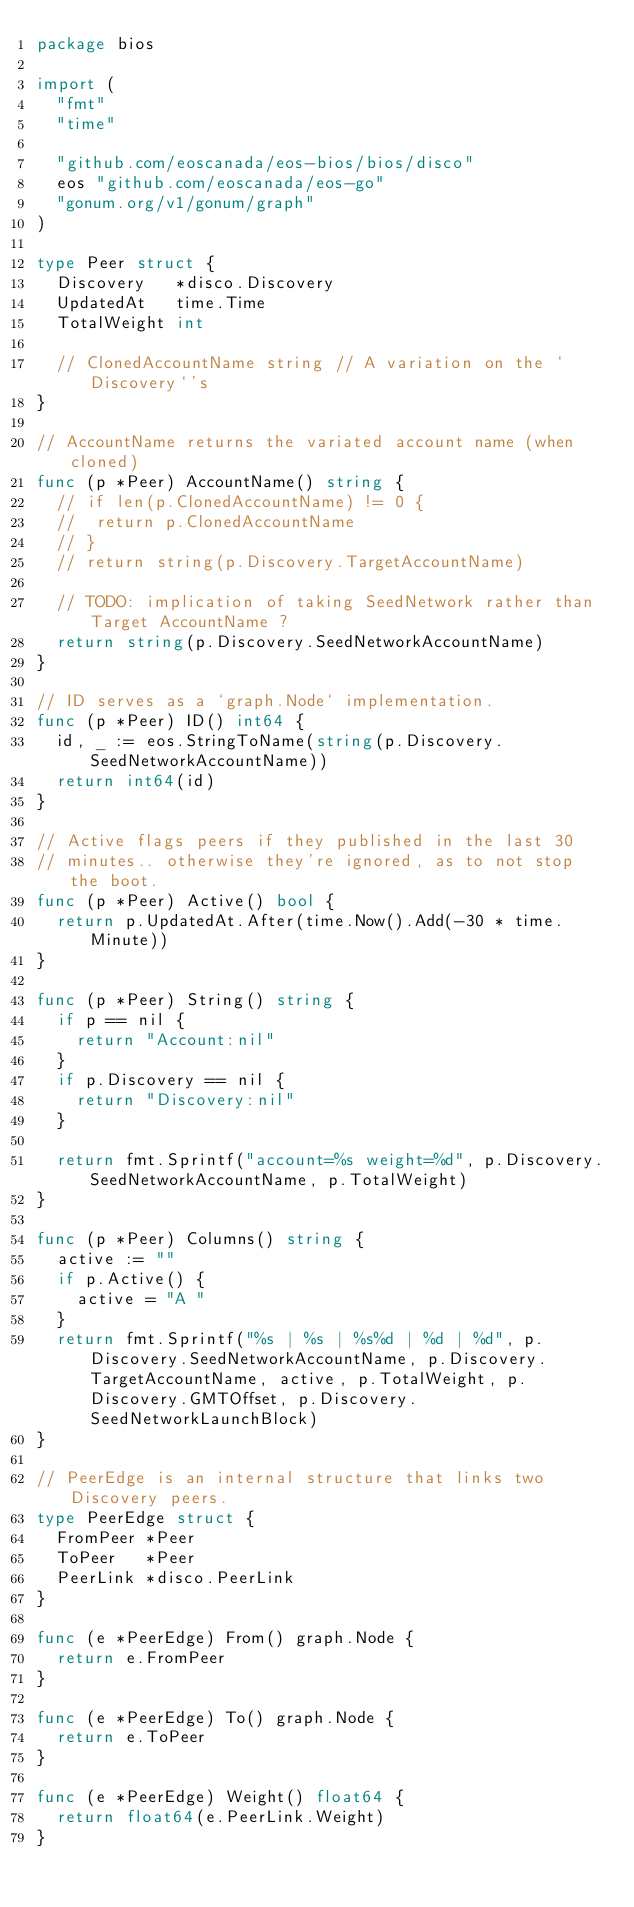Convert code to text. <code><loc_0><loc_0><loc_500><loc_500><_Go_>package bios

import (
	"fmt"
	"time"

	"github.com/eoscanada/eos-bios/bios/disco"
	eos "github.com/eoscanada/eos-go"
	"gonum.org/v1/gonum/graph"
)

type Peer struct {
	Discovery   *disco.Discovery
	UpdatedAt   time.Time
	TotalWeight int

	// ClonedAccountName string // A variation on the `Discovery`'s
}

// AccountName returns the variated account name (when cloned)
func (p *Peer) AccountName() string {
	// if len(p.ClonedAccountName) != 0 {
	// 	return p.ClonedAccountName
	// }
	// return string(p.Discovery.TargetAccountName)

	// TODO: implication of taking SeedNetwork rather than Target AccountName ?
	return string(p.Discovery.SeedNetworkAccountName)
}

// ID serves as a `graph.Node` implementation.
func (p *Peer) ID() int64 {
	id, _ := eos.StringToName(string(p.Discovery.SeedNetworkAccountName))
	return int64(id)
}

// Active flags peers if they published in the last 30
// minutes.. otherwise they're ignored, as to not stop the boot.
func (p *Peer) Active() bool {
	return p.UpdatedAt.After(time.Now().Add(-30 * time.Minute))
}

func (p *Peer) String() string {
	if p == nil {
		return "Account:nil"
	}
	if p.Discovery == nil {
		return "Discovery:nil"
	}

	return fmt.Sprintf("account=%s weight=%d", p.Discovery.SeedNetworkAccountName, p.TotalWeight)
}

func (p *Peer) Columns() string {
	active := ""
	if p.Active() {
		active = "A "
	}
	return fmt.Sprintf("%s | %s | %s%d | %d | %d", p.Discovery.SeedNetworkAccountName, p.Discovery.TargetAccountName, active, p.TotalWeight, p.Discovery.GMTOffset, p.Discovery.SeedNetworkLaunchBlock)
}

// PeerEdge is an internal structure that links two Discovery peers.
type PeerEdge struct {
	FromPeer *Peer
	ToPeer   *Peer
	PeerLink *disco.PeerLink
}

func (e *PeerEdge) From() graph.Node {
	return e.FromPeer
}

func (e *PeerEdge) To() graph.Node {
	return e.ToPeer
}

func (e *PeerEdge) Weight() float64 {
	return float64(e.PeerLink.Weight)
}
</code> 